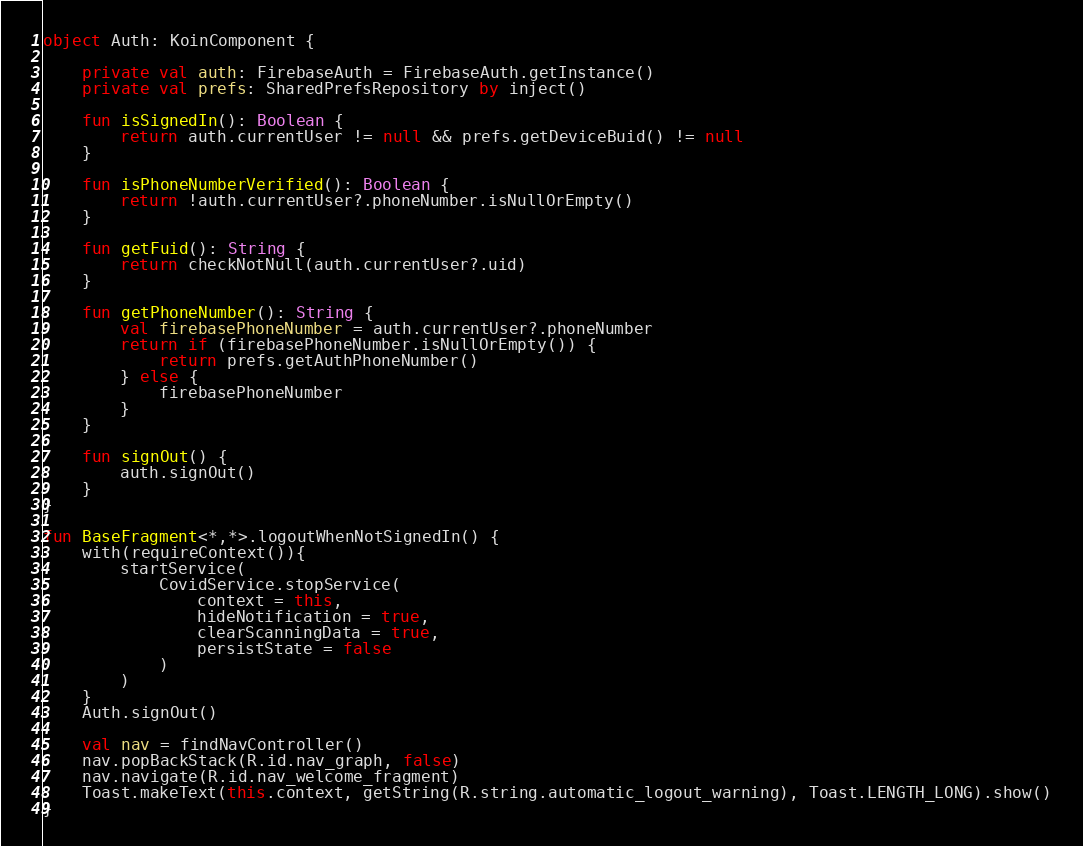<code> <loc_0><loc_0><loc_500><loc_500><_Kotlin_>object Auth: KoinComponent {

    private val auth: FirebaseAuth = FirebaseAuth.getInstance()
    private val prefs: SharedPrefsRepository by inject()

    fun isSignedIn(): Boolean {
        return auth.currentUser != null && prefs.getDeviceBuid() != null
    }

    fun isPhoneNumberVerified(): Boolean {
        return !auth.currentUser?.phoneNumber.isNullOrEmpty()
    }

    fun getFuid(): String {
        return checkNotNull(auth.currentUser?.uid)
    }

    fun getPhoneNumber(): String {
        val firebasePhoneNumber = auth.currentUser?.phoneNumber
        return if (firebasePhoneNumber.isNullOrEmpty()) {
            return prefs.getAuthPhoneNumber()
        } else {
            firebasePhoneNumber
        }
    }

    fun signOut() {
        auth.signOut()
    }
}

fun BaseFragment<*,*>.logoutWhenNotSignedIn() {
    with(requireContext()){
        startService(
            CovidService.stopService(
                context = this,
                hideNotification = true,
                clearScanningData = true,
                persistState = false
            )
        )
    }
    Auth.signOut()

    val nav = findNavController()
    nav.popBackStack(R.id.nav_graph, false)
    nav.navigate(R.id.nav_welcome_fragment)
    Toast.makeText(this.context, getString(R.string.automatic_logout_warning), Toast.LENGTH_LONG).show()
}
</code> 